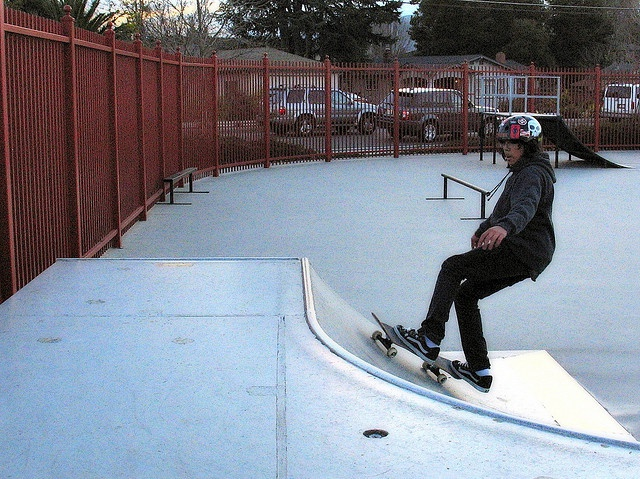Describe the objects in this image and their specific colors. I can see people in salmon, black, gray, and darkgray tones, car in salmon, black, gray, and darkgray tones, car in salmon, black, gray, and darkgray tones, car in salmon, gray, black, lavender, and darkgray tones, and skateboard in salmon, gray, black, darkgray, and blue tones in this image. 